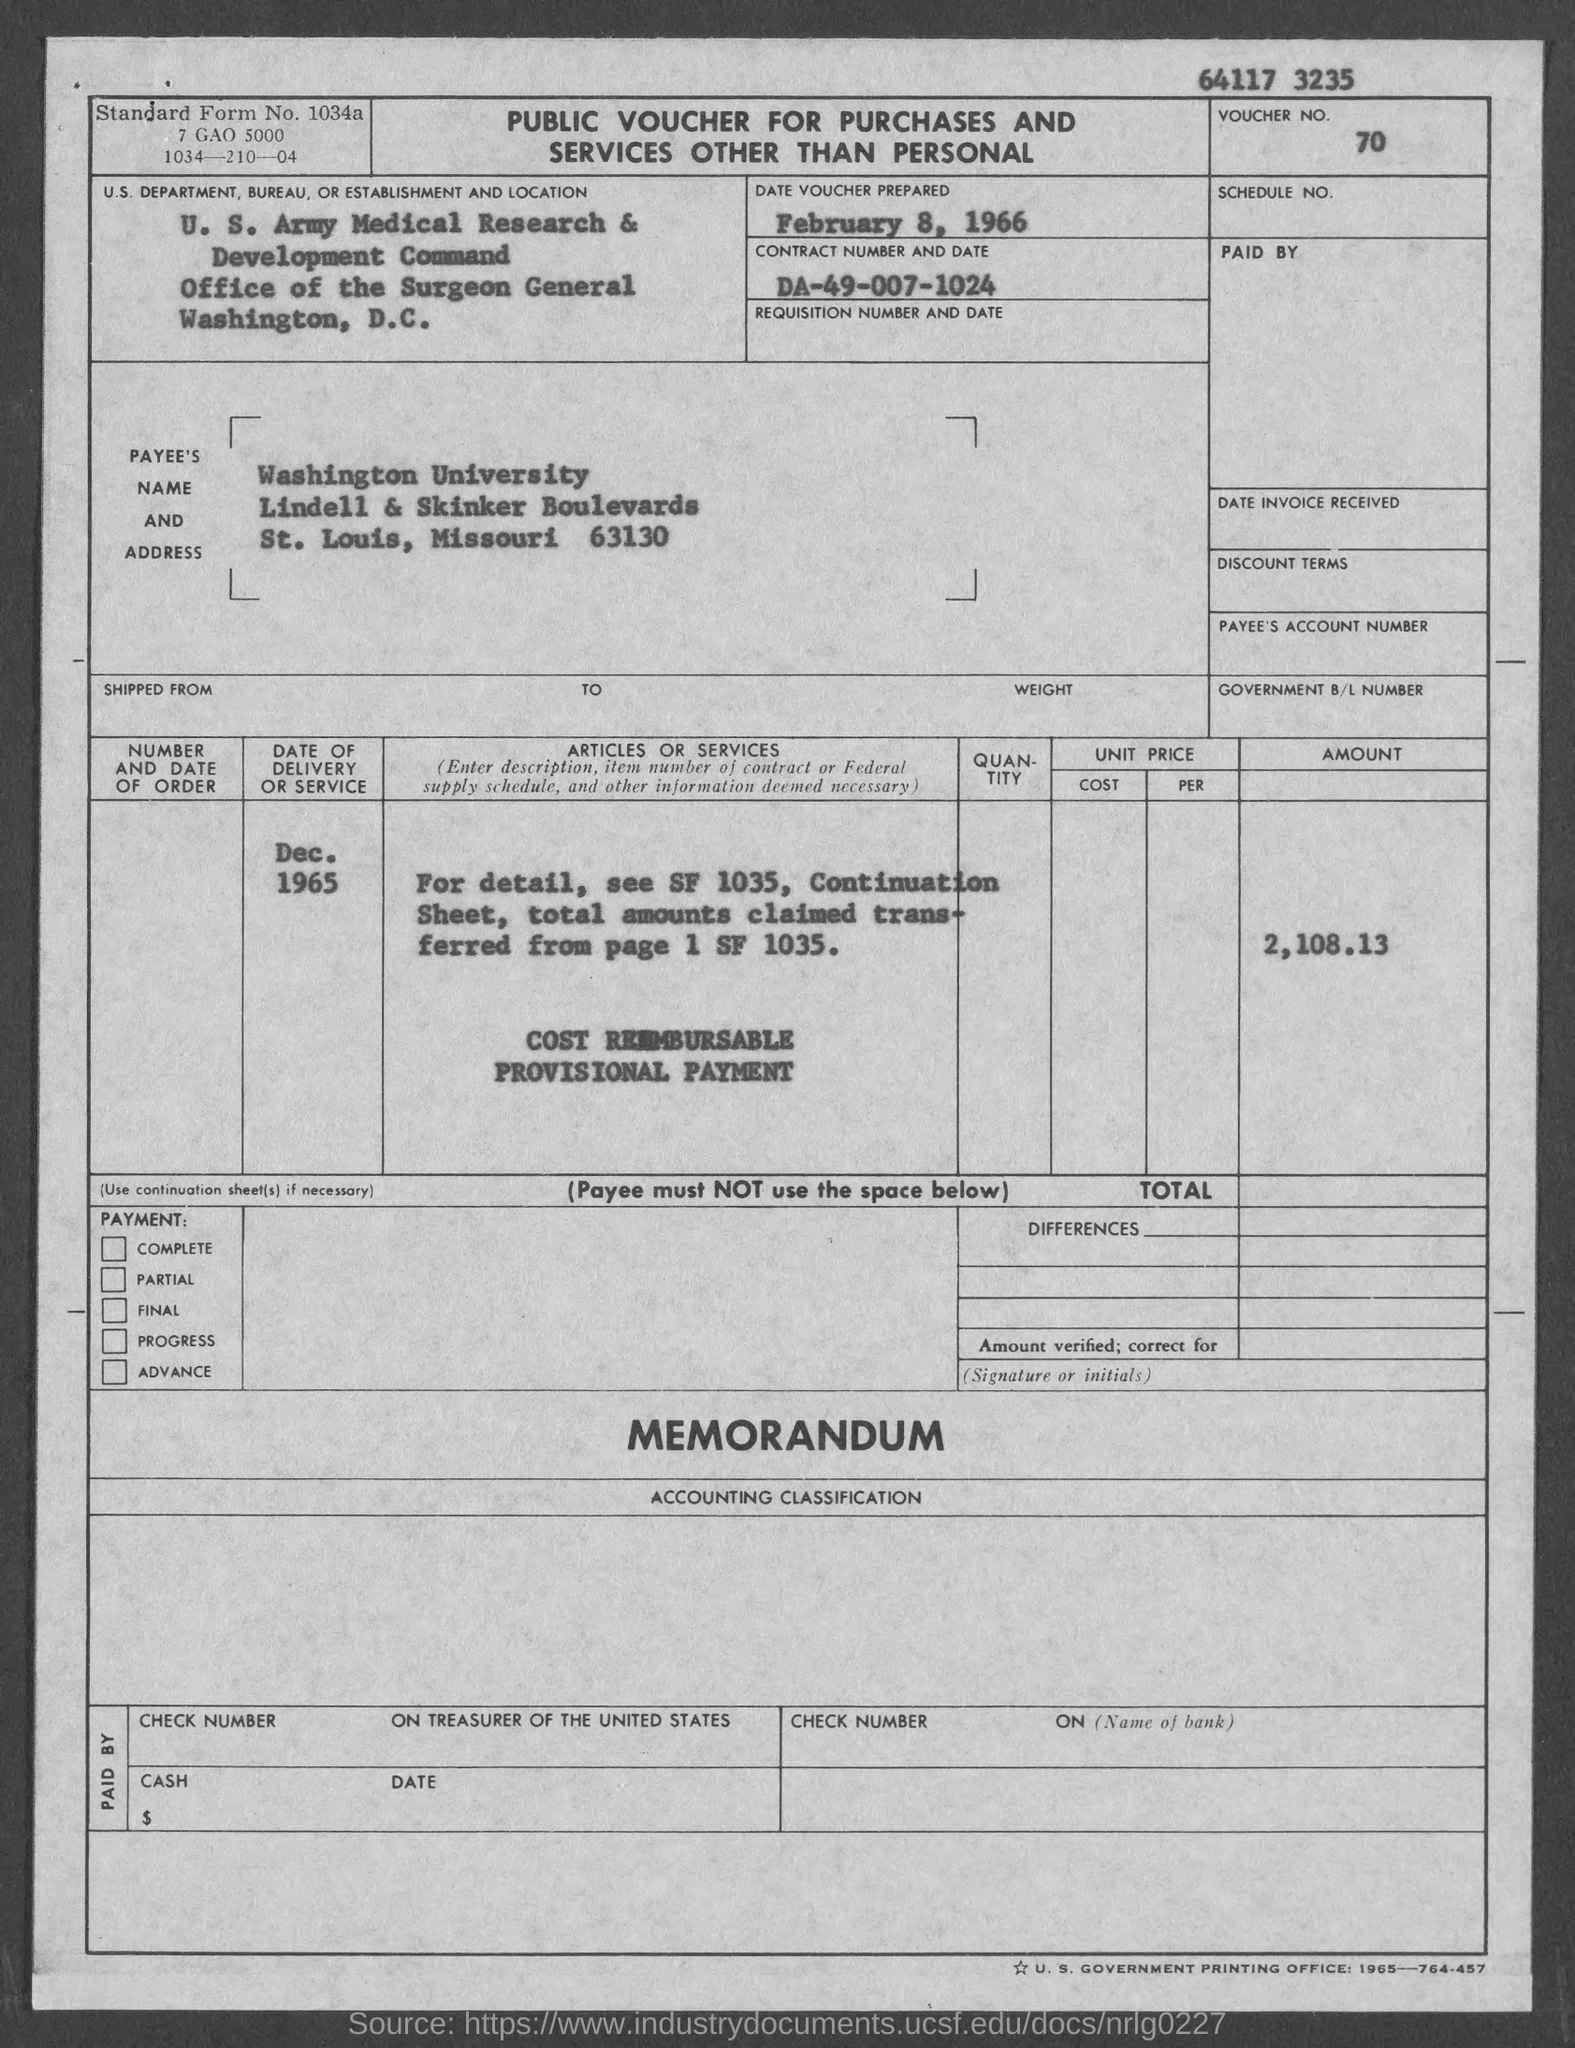List a handful of essential elements in this visual. What is the voucher number?" the representative asked, specifying "70... The standard form number is 1034a.. The Office of the Surgeon General is located in the city of Washington. Washington University is located in the state of Missouri. The contract number is DA-49-007-1024. 